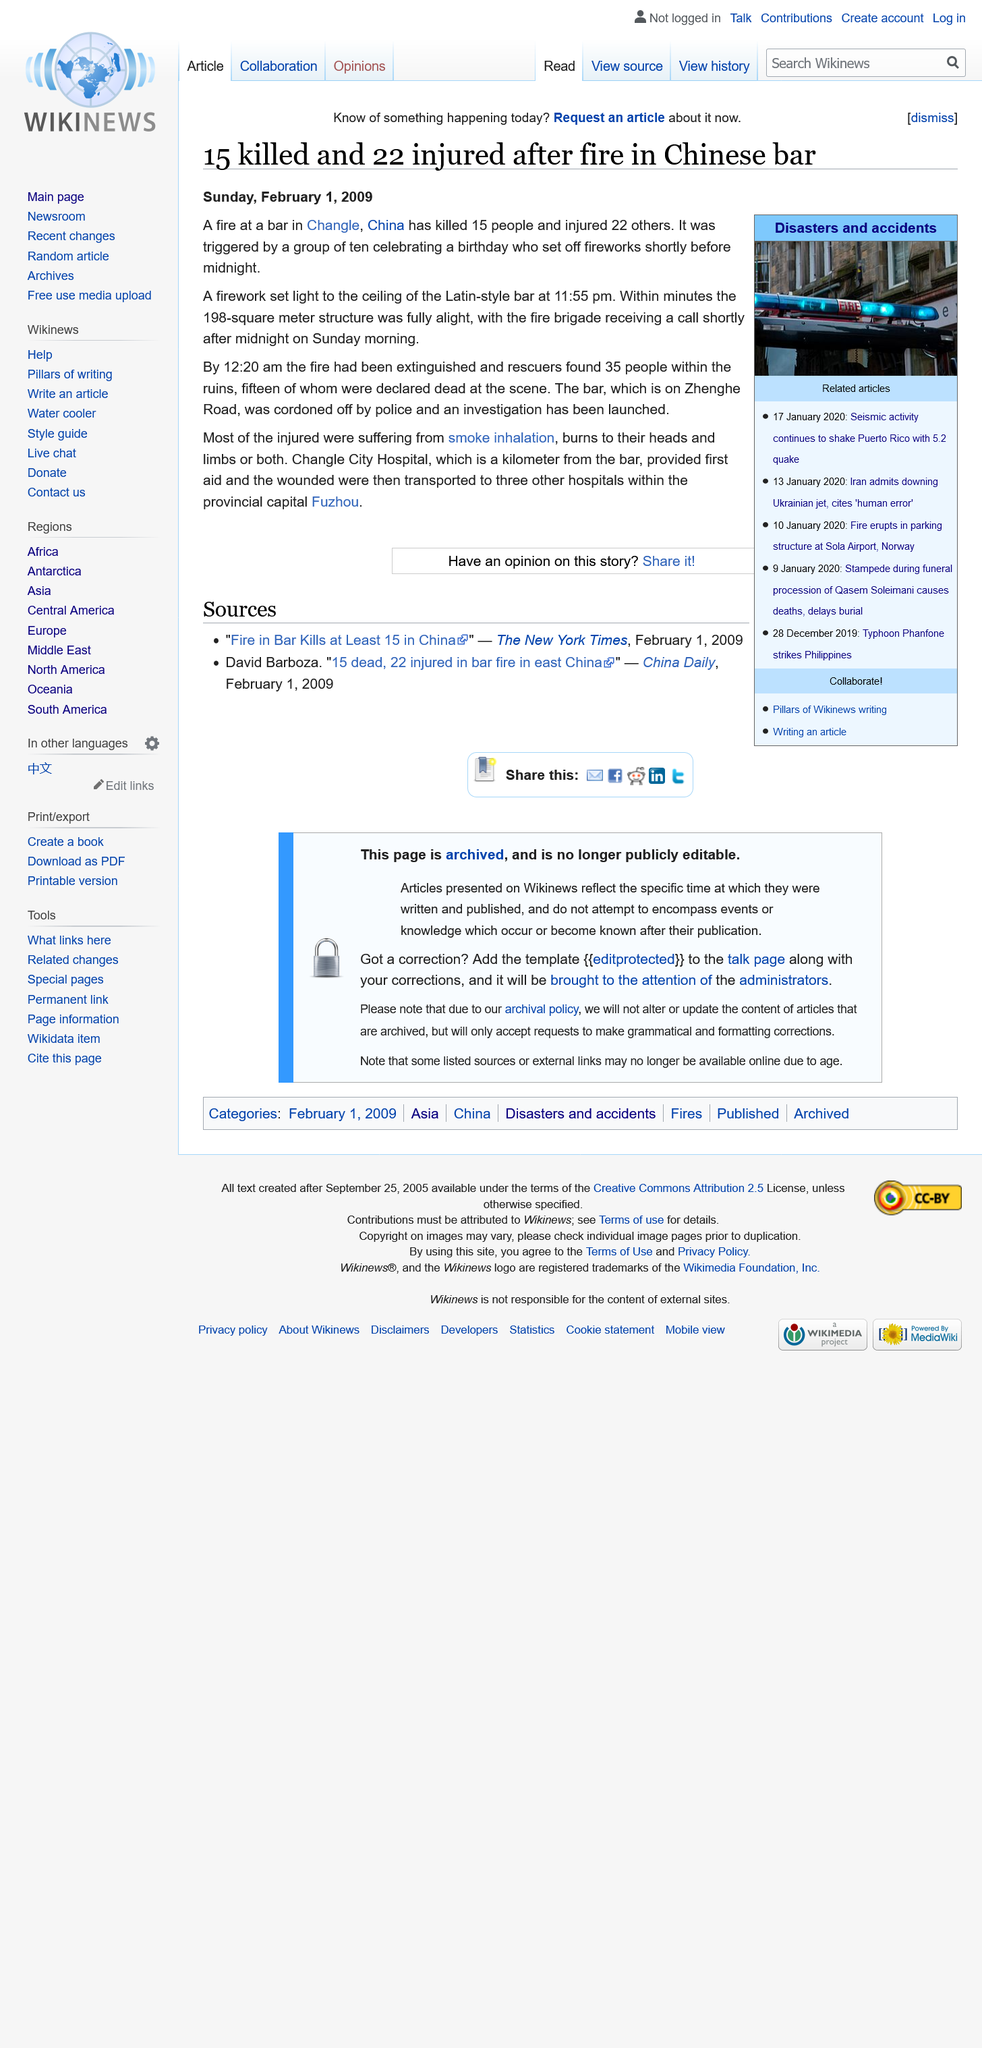Point out several critical features in this image. Following the incident where the three individuals sustained injuries from a firework explosion at a bar in Changle City, the first aid was provided by Changle City Hospital, located a kilometer away from the bar, before the wounded were transported to three other hospitals within the provincial capital Fuzhou for further treatment. On the evening of December 31st, at a bar in Changle, China, a group of ten individuals were celebrating a birthday. In order to commemorate the occasion, they decided to set off fireworks. Unfortunately, this decision led to a catastrophic fire that caused significant damage to the bar. The blaze was sparked shortly before midnight and quickly spread, engulfing the building and its surroundings. Fortunately, no one was harmed in the fire, but the bar was left severely damaged, and the investigation into the cause of the blaze is ongoing. The cause of most of the injuries was smoke inhalation, burns to the heads and limbs, or both. Many of the injured individuals were affected by these injuries. 